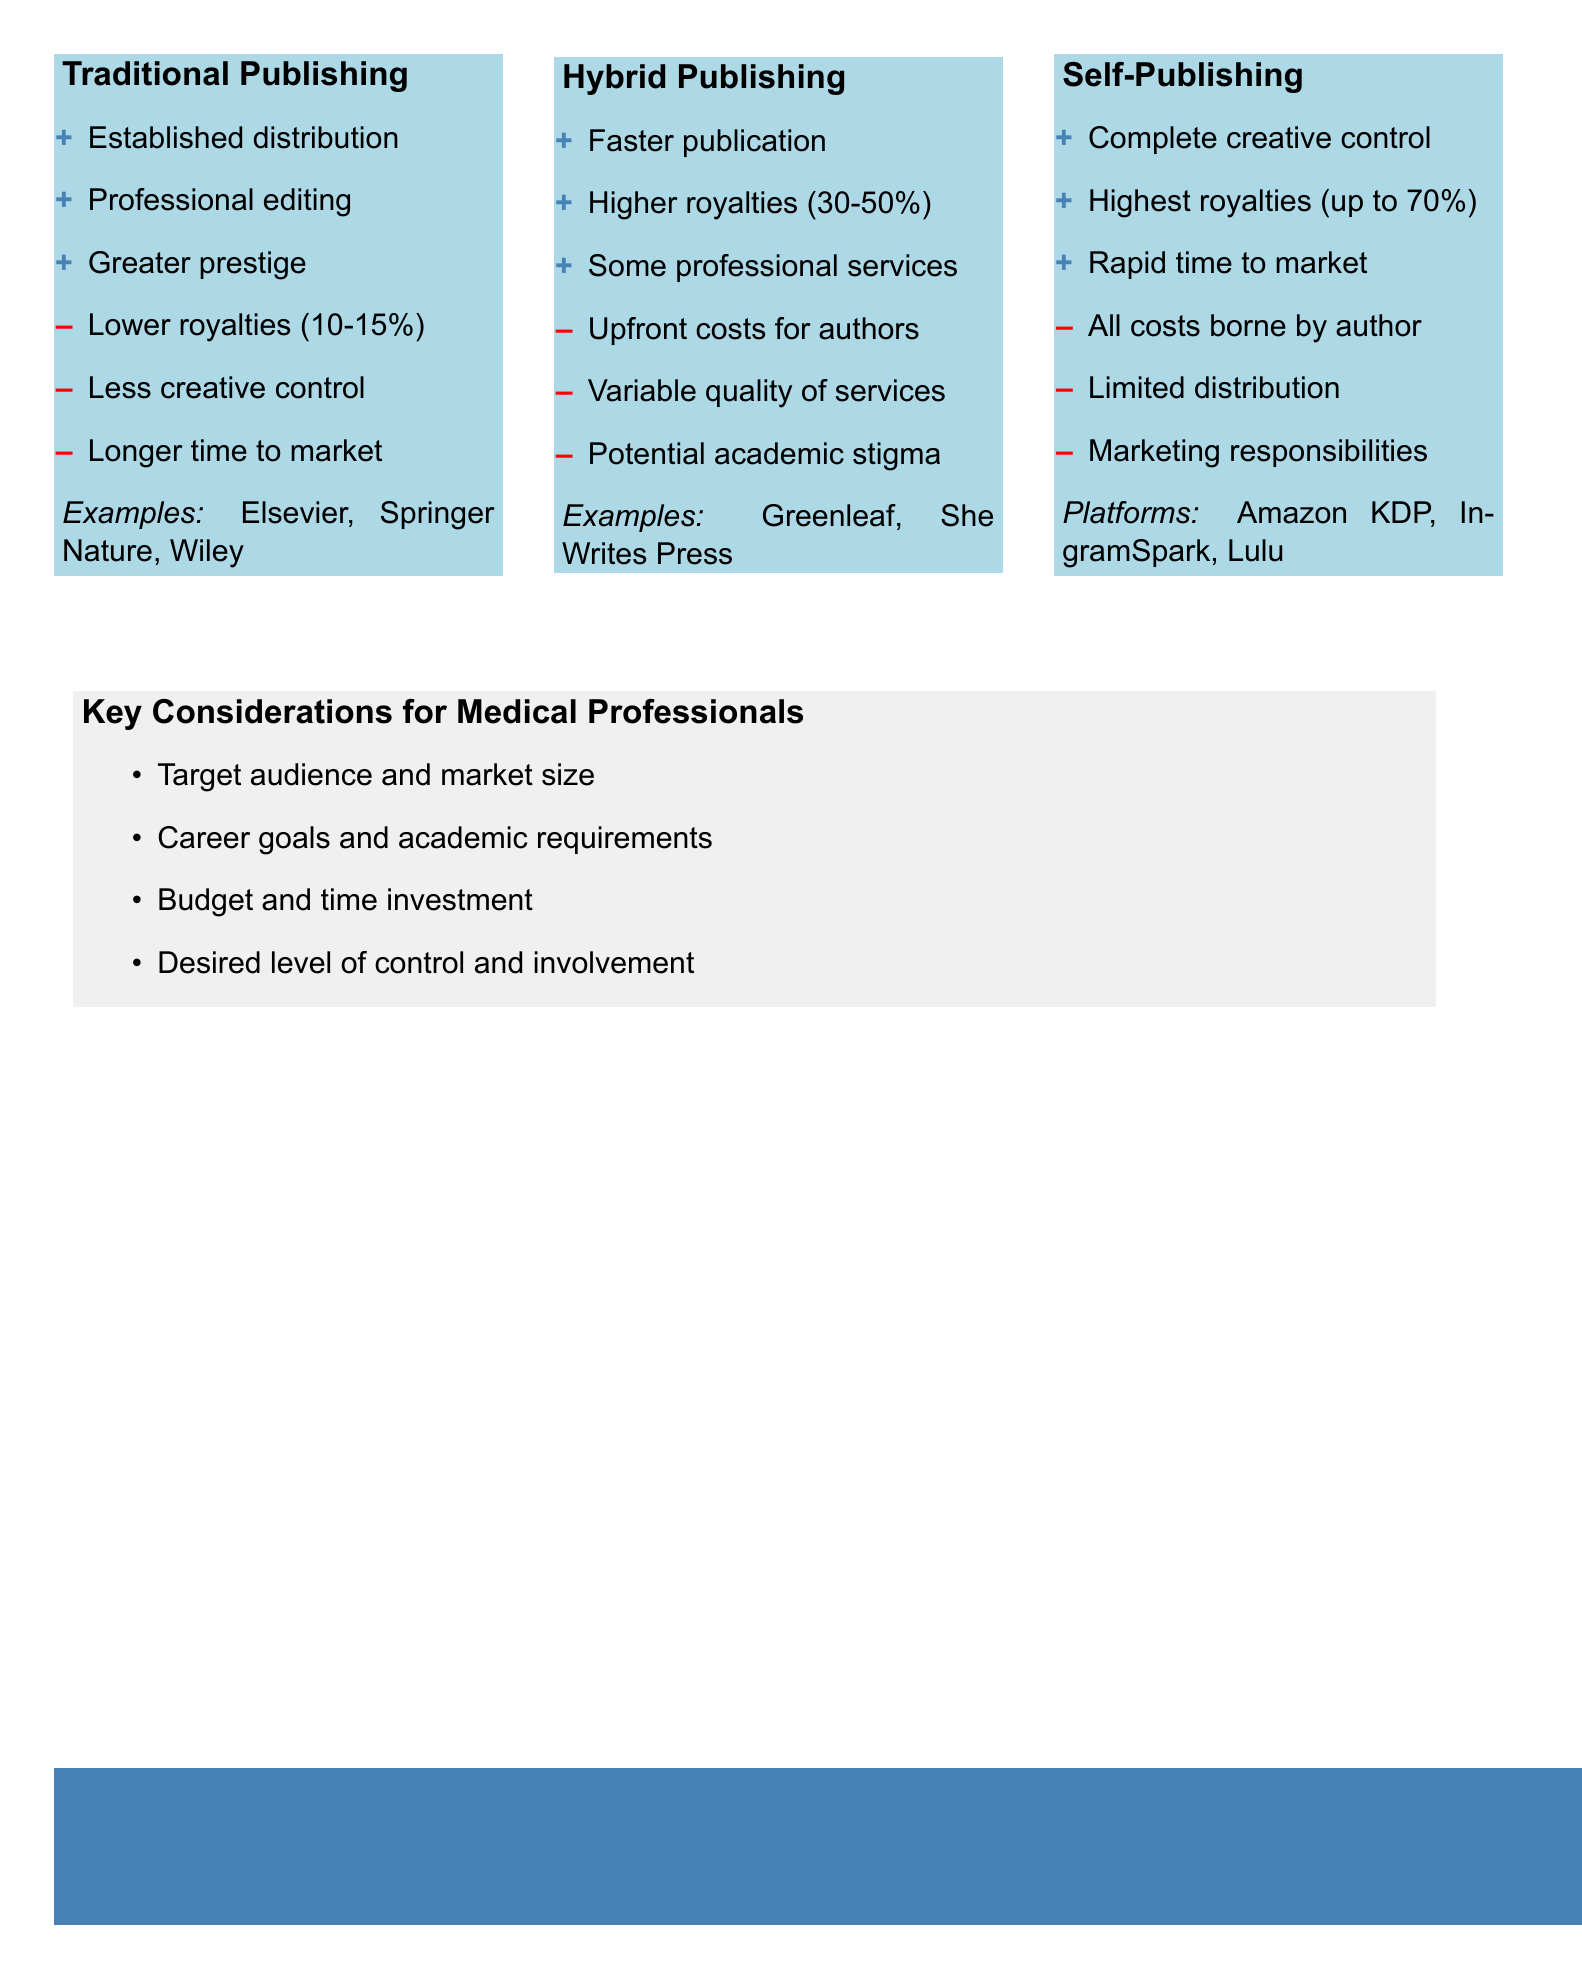What are some examples of traditional publishing? The document lists examples of traditional publishing companies as Elsevier, Springer Nature, and Wiley.
Answer: Elsevier, Springer Nature, Wiley What is the royalty range for traditional publishing? The document states that traditional publishing offers lower royalties, specifically between 10 to 15 percent.
Answer: 10-15% What is a pro of self-publishing? The document provides three positive aspects of self-publishing, one of which is complete creative control.
Answer: Complete creative control What is a potential downside of hybrid publishing? The document lists several drawbacks of hybrid publishing, one being upfront costs for authors.
Answer: Upfront costs for authors What is the highest royalty potential mentioned? The document indicates that self-publishing can yield the highest royalties, which can be up to 70 percent.
Answer: up to 70% How many key considerations are there for medical professionals? The document outlines four key considerations for medical professionals when choosing a publishing route.
Answer: Four What is one example of a self-publishing platform? The document mentions several platforms for self-publishing, including Amazon KDP.
Answer: Amazon KDP What publishing route offers faster publication? The document states that hybrid publishing provides faster publication compared to other routes.
Answer: Hybrid Publishing What factor does the document suggest could influence a medical professional's choice of publishing route? The document lists several factors, one being career goals and academic requirements, that could influence the choice of publishing route.
Answer: Career goals and academic requirements 